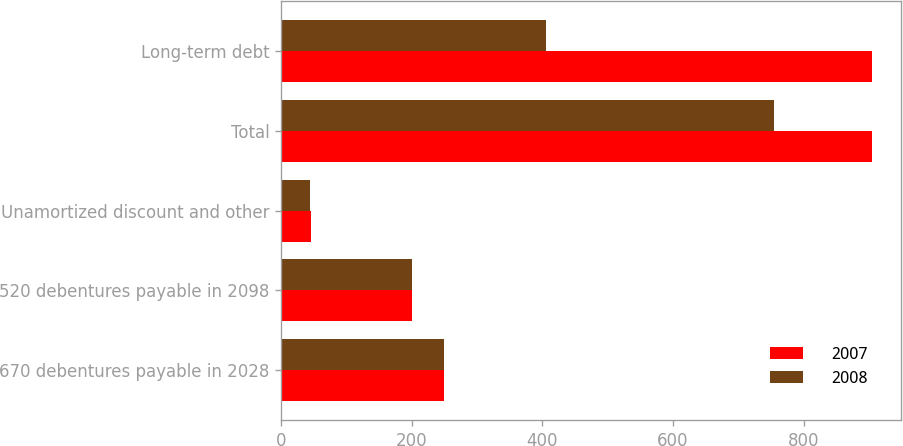Convert chart to OTSL. <chart><loc_0><loc_0><loc_500><loc_500><stacked_bar_chart><ecel><fcel>670 debentures payable in 2028<fcel>520 debentures payable in 2098<fcel>Unamortized discount and other<fcel>Total<fcel>Long-term debt<nl><fcel>2007<fcel>250<fcel>200<fcel>45.6<fcel>904.4<fcel>904.4<nl><fcel>2008<fcel>250<fcel>200<fcel>44.3<fcel>753.9<fcel>405.7<nl></chart> 